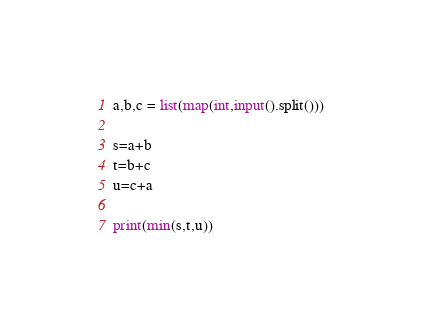Convert code to text. <code><loc_0><loc_0><loc_500><loc_500><_Python_>a,b,c = list(map(int,input().split()))

s=a+b
t=b+c
u=c+a

print(min(s,t,u))</code> 